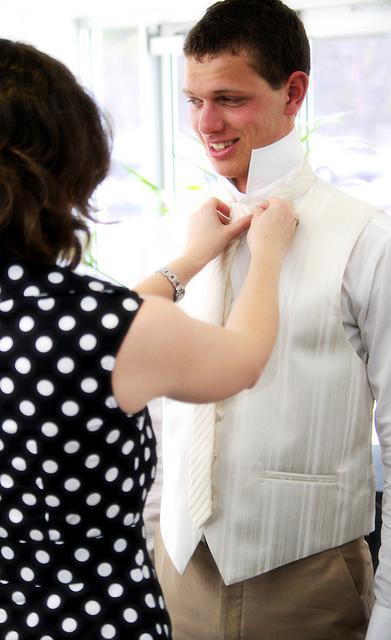How many people can you see?
Give a very brief answer. 2. 